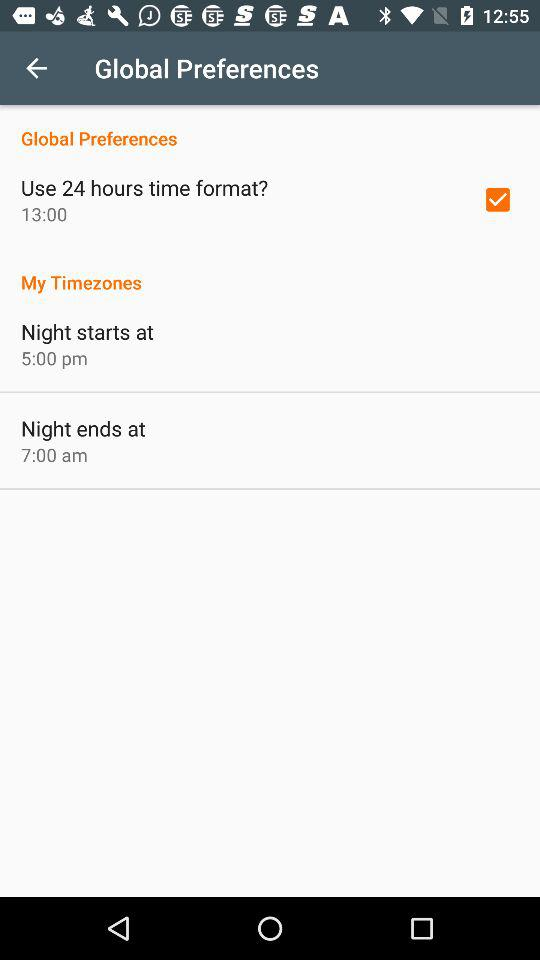At what time does the night end? The night ends at 7:00 a.m. 